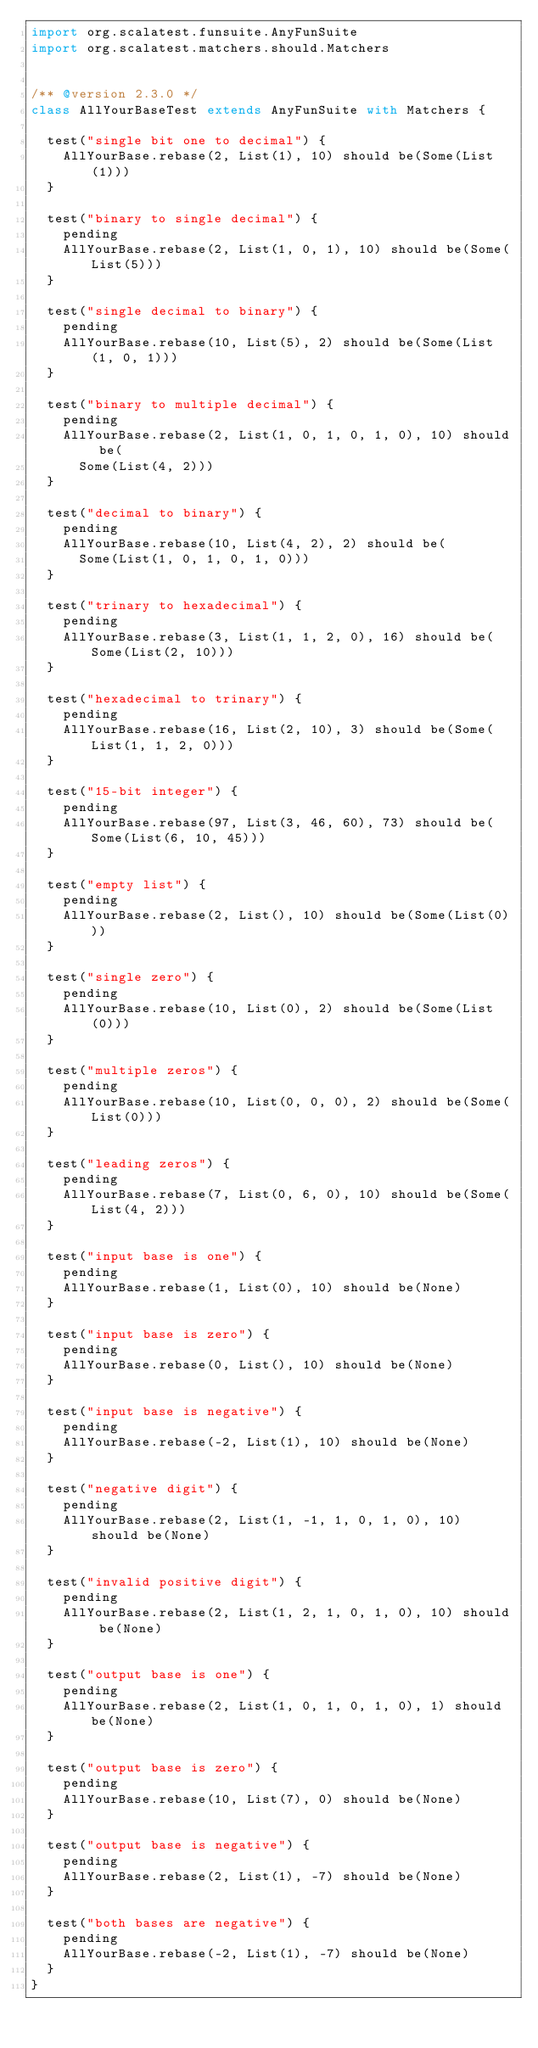<code> <loc_0><loc_0><loc_500><loc_500><_Scala_>import org.scalatest.funsuite.AnyFunSuite
import org.scalatest.matchers.should.Matchers


/** @version 2.3.0 */
class AllYourBaseTest extends AnyFunSuite with Matchers {

  test("single bit one to decimal") {
    AllYourBase.rebase(2, List(1), 10) should be(Some(List(1)))
  }

  test("binary to single decimal") {
    pending
    AllYourBase.rebase(2, List(1, 0, 1), 10) should be(Some(List(5)))
  }

  test("single decimal to binary") {
    pending
    AllYourBase.rebase(10, List(5), 2) should be(Some(List(1, 0, 1)))
  }

  test("binary to multiple decimal") {
    pending
    AllYourBase.rebase(2, List(1, 0, 1, 0, 1, 0), 10) should be(
      Some(List(4, 2)))
  }

  test("decimal to binary") {
    pending
    AllYourBase.rebase(10, List(4, 2), 2) should be(
      Some(List(1, 0, 1, 0, 1, 0)))
  }

  test("trinary to hexadecimal") {
    pending
    AllYourBase.rebase(3, List(1, 1, 2, 0), 16) should be(Some(List(2, 10)))
  }

  test("hexadecimal to trinary") {
    pending
    AllYourBase.rebase(16, List(2, 10), 3) should be(Some(List(1, 1, 2, 0)))
  }

  test("15-bit integer") {
    pending
    AllYourBase.rebase(97, List(3, 46, 60), 73) should be(Some(List(6, 10, 45)))
  }

  test("empty list") {
    pending
    AllYourBase.rebase(2, List(), 10) should be(Some(List(0)))
  }

  test("single zero") {
    pending
    AllYourBase.rebase(10, List(0), 2) should be(Some(List(0)))
  }

  test("multiple zeros") {
    pending
    AllYourBase.rebase(10, List(0, 0, 0), 2) should be(Some(List(0)))
  }

  test("leading zeros") {
    pending
    AllYourBase.rebase(7, List(0, 6, 0), 10) should be(Some(List(4, 2)))
  }

  test("input base is one") {
    pending
    AllYourBase.rebase(1, List(0), 10) should be(None)
  }

  test("input base is zero") {
    pending
    AllYourBase.rebase(0, List(), 10) should be(None)
  }

  test("input base is negative") {
    pending
    AllYourBase.rebase(-2, List(1), 10) should be(None)
  }

  test("negative digit") {
    pending
    AllYourBase.rebase(2, List(1, -1, 1, 0, 1, 0), 10) should be(None)
  }

  test("invalid positive digit") {
    pending
    AllYourBase.rebase(2, List(1, 2, 1, 0, 1, 0), 10) should be(None)
  }

  test("output base is one") {
    pending
    AllYourBase.rebase(2, List(1, 0, 1, 0, 1, 0), 1) should be(None)
  }

  test("output base is zero") {
    pending
    AllYourBase.rebase(10, List(7), 0) should be(None)
  }

  test("output base is negative") {
    pending
    AllYourBase.rebase(2, List(1), -7) should be(None)
  }

  test("both bases are negative") {
    pending
    AllYourBase.rebase(-2, List(1), -7) should be(None)
  }
}
</code> 